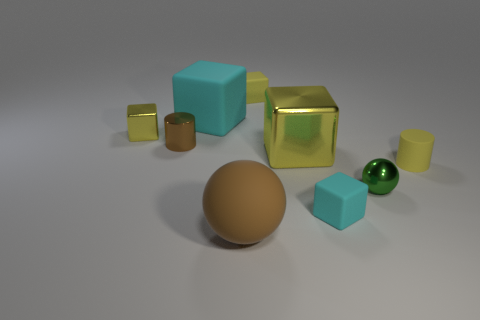What number of small yellow rubber objects are behind the yellow shiny thing that is behind the small brown cylinder?
Keep it short and to the point. 1. Is there anything else that has the same shape as the small brown metallic thing?
Make the answer very short. Yes. Does the big matte object that is behind the metallic ball have the same color as the tiny matte object in front of the tiny green ball?
Provide a succinct answer. Yes. Is the number of purple spheres less than the number of small yellow matte blocks?
Keep it short and to the point. Yes. The tiny yellow matte object behind the yellow shiny thing that is in front of the small brown metal cylinder is what shape?
Offer a terse response. Cube. Is there any other thing that has the same size as the brown cylinder?
Your response must be concise. Yes. What is the shape of the small yellow object behind the yellow shiny thing to the left of the small yellow rubber object that is to the left of the big yellow metal thing?
Provide a succinct answer. Cube. How many things are either tiny objects left of the big yellow cube or objects in front of the tiny ball?
Your response must be concise. 5. There is a green metal ball; does it have the same size as the yellow cube that is left of the small brown cylinder?
Give a very brief answer. Yes. Is the large yellow thing behind the yellow cylinder made of the same material as the brown thing that is behind the tiny sphere?
Offer a very short reply. Yes. 